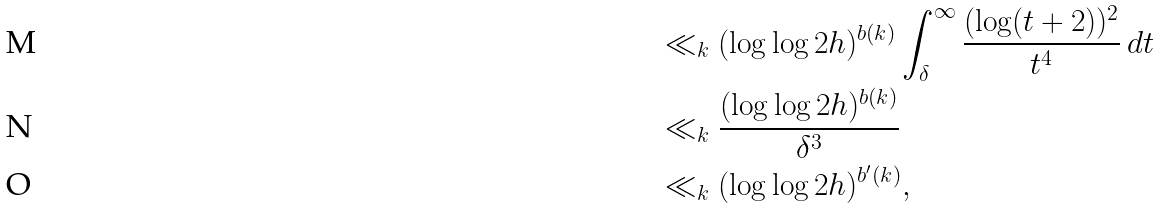<formula> <loc_0><loc_0><loc_500><loc_500>& \ll _ { k } ( \log \log 2 h ) ^ { b ( k ) } \int _ { \delta } ^ { \infty } \frac { ( \log ( t + 2 ) ) ^ { 2 } } { t ^ { 4 } } \, d t \\ & \ll _ { k } \frac { ( \log \log 2 h ) ^ { b ( k ) } } { \delta ^ { 3 } } \\ & \ll _ { k } ( \log \log 2 h ) ^ { b ^ { \prime } ( k ) } ,</formula> 